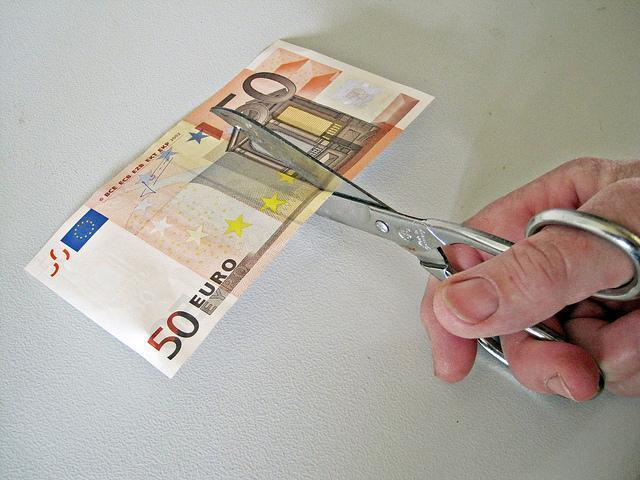How many train cars?
Give a very brief answer. 0. 